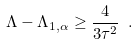Convert formula to latex. <formula><loc_0><loc_0><loc_500><loc_500>\Lambda - \Lambda _ { 1 , \alpha } \geq \frac { 4 } { 3 \tau ^ { 2 } } \ .</formula> 